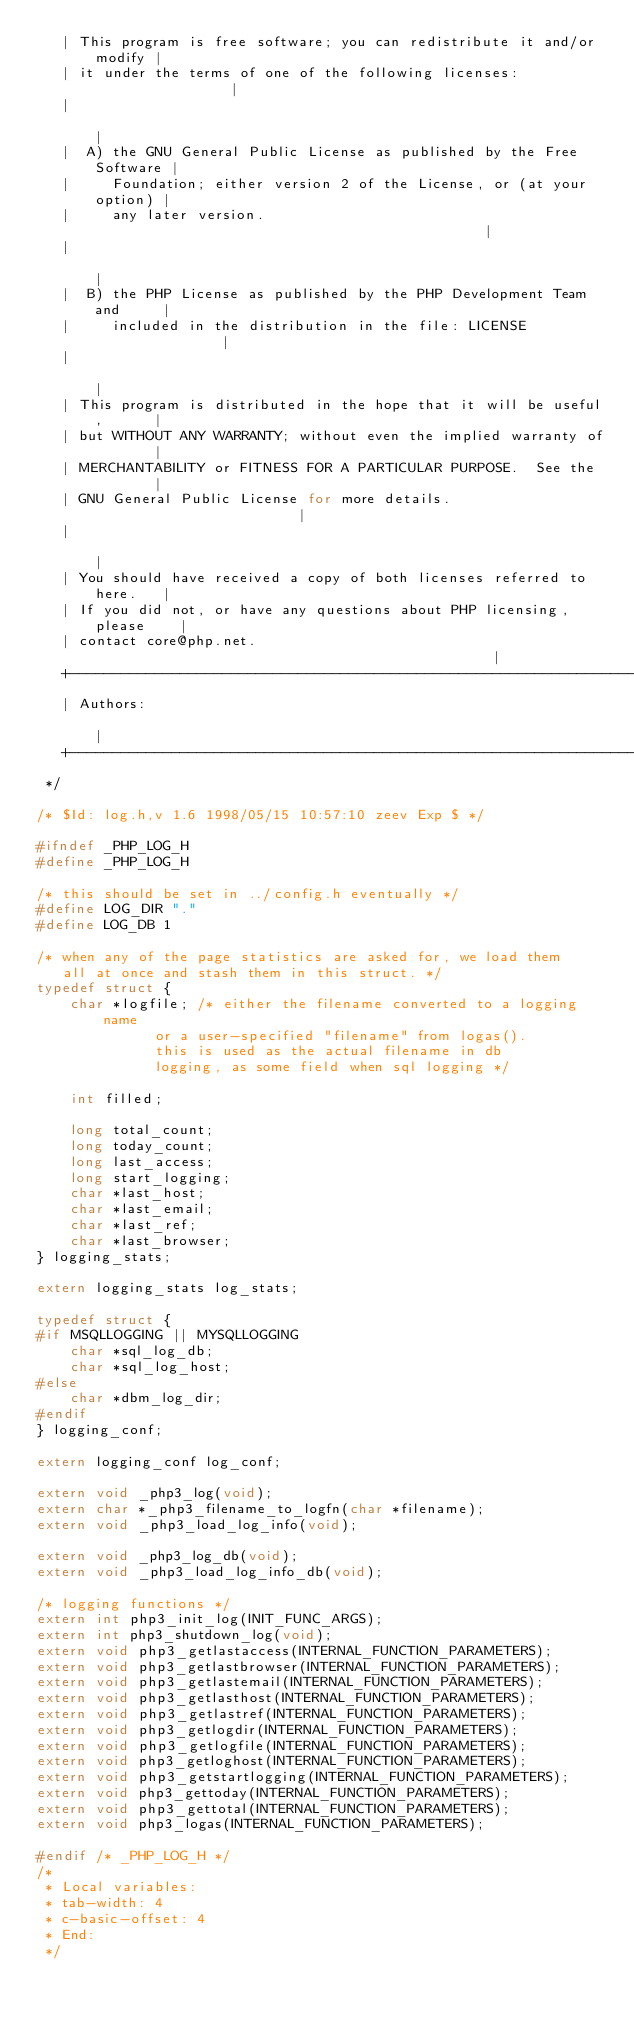Convert code to text. <code><loc_0><loc_0><loc_500><loc_500><_C_>   | This program is free software; you can redistribute it and/or modify |
   | it under the terms of one of the following licenses:                 |
   |                                                                      |
   |  A) the GNU General Public License as published by the Free Software |
   |     Foundation; either version 2 of the License, or (at your option) |
   |     any later version.                                               |
   |                                                                      |
   |  B) the PHP License as published by the PHP Development Team and     |
   |     included in the distribution in the file: LICENSE                |
   |                                                                      |
   | This program is distributed in the hope that it will be useful,      |
   | but WITHOUT ANY WARRANTY; without even the implied warranty of       |
   | MERCHANTABILITY or FITNESS FOR A PARTICULAR PURPOSE.  See the        |
   | GNU General Public License for more details.                         |
   |                                                                      |
   | You should have received a copy of both licenses referred to here.   |
   | If you did not, or have any questions about PHP licensing, please    |
   | contact core@php.net.                                                |
   +----------------------------------------------------------------------+
   | Authors:                                                             |
   +----------------------------------------------------------------------+
 */

/* $Id: log.h,v 1.6 1998/05/15 10:57:10 zeev Exp $ */

#ifndef _PHP_LOG_H
#define _PHP_LOG_H

/* this should be set in ../config.h eventually */
#define LOG_DIR "."
#define LOG_DB 1

/* when any of the page statistics are asked for, we load them
   all at once and stash them in this struct. */
typedef struct {
	char *logfile; /* either the filename converted to a logging name
			  or a user-specified "filename" from logas().
			  this is used as the actual filename in db
			  logging, as some field when sql logging */

	int filled;

	long total_count;
	long today_count;
	long last_access;
	long start_logging;
	char *last_host;
	char *last_email;
	char *last_ref;
	char *last_browser;	
} logging_stats;

extern logging_stats log_stats;

typedef struct {
#if MSQLLOGGING || MYSQLLOGGING
	char *sql_log_db;
	char *sql_log_host;
#else
	char *dbm_log_dir;
#endif
} logging_conf;

extern logging_conf log_conf;

extern void _php3_log(void);
extern char *_php3_filename_to_logfn(char *filename);
extern void _php3_load_log_info(void);

extern void _php3_log_db(void);
extern void _php3_load_log_info_db(void);

/* logging functions */
extern int php3_init_log(INIT_FUNC_ARGS);
extern int php3_shutdown_log(void);
extern void php3_getlastaccess(INTERNAL_FUNCTION_PARAMETERS);
extern void php3_getlastbrowser(INTERNAL_FUNCTION_PARAMETERS);
extern void php3_getlastemail(INTERNAL_FUNCTION_PARAMETERS);
extern void php3_getlasthost(INTERNAL_FUNCTION_PARAMETERS);
extern void php3_getlastref(INTERNAL_FUNCTION_PARAMETERS);
extern void php3_getlogdir(INTERNAL_FUNCTION_PARAMETERS);
extern void php3_getlogfile(INTERNAL_FUNCTION_PARAMETERS);
extern void php3_getloghost(INTERNAL_FUNCTION_PARAMETERS);
extern void php3_getstartlogging(INTERNAL_FUNCTION_PARAMETERS);
extern void php3_gettoday(INTERNAL_FUNCTION_PARAMETERS);
extern void php3_gettotal(INTERNAL_FUNCTION_PARAMETERS);
extern void php3_logas(INTERNAL_FUNCTION_PARAMETERS);

#endif /* _PHP_LOG_H */
/*
 * Local variables:
 * tab-width: 4
 * c-basic-offset: 4
 * End:
 */
</code> 